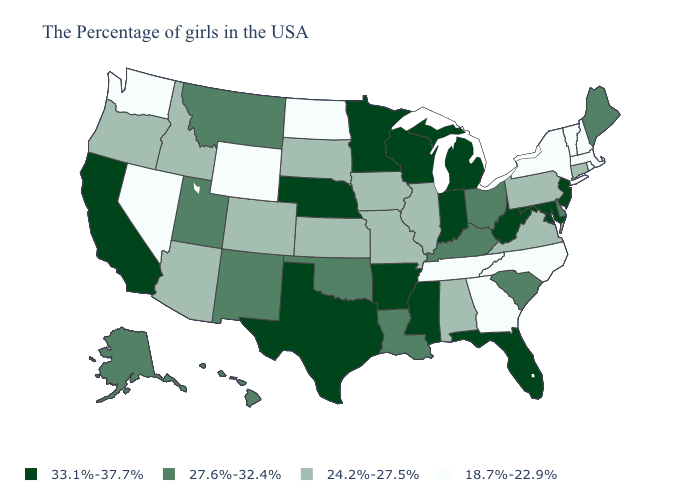Which states have the lowest value in the USA?
Concise answer only. Massachusetts, Rhode Island, New Hampshire, Vermont, New York, North Carolina, Georgia, Tennessee, North Dakota, Wyoming, Nevada, Washington. Does New Hampshire have the lowest value in the USA?
Short answer required. Yes. What is the highest value in states that border Indiana?
Write a very short answer. 33.1%-37.7%. Which states have the lowest value in the West?
Be succinct. Wyoming, Nevada, Washington. Among the states that border Florida , which have the highest value?
Give a very brief answer. Alabama. Does the first symbol in the legend represent the smallest category?
Quick response, please. No. Does Georgia have a lower value than Oklahoma?
Short answer required. Yes. Name the states that have a value in the range 27.6%-32.4%?
Be succinct. Maine, Delaware, South Carolina, Ohio, Kentucky, Louisiana, Oklahoma, New Mexico, Utah, Montana, Alaska, Hawaii. Name the states that have a value in the range 18.7%-22.9%?
Quick response, please. Massachusetts, Rhode Island, New Hampshire, Vermont, New York, North Carolina, Georgia, Tennessee, North Dakota, Wyoming, Nevada, Washington. Does Arkansas have the same value as Michigan?
Be succinct. Yes. What is the lowest value in the Northeast?
Concise answer only. 18.7%-22.9%. What is the value of Wisconsin?
Be succinct. 33.1%-37.7%. How many symbols are there in the legend?
Answer briefly. 4. Does Colorado have a lower value than Florida?
Quick response, please. Yes. Name the states that have a value in the range 27.6%-32.4%?
Short answer required. Maine, Delaware, South Carolina, Ohio, Kentucky, Louisiana, Oklahoma, New Mexico, Utah, Montana, Alaska, Hawaii. 